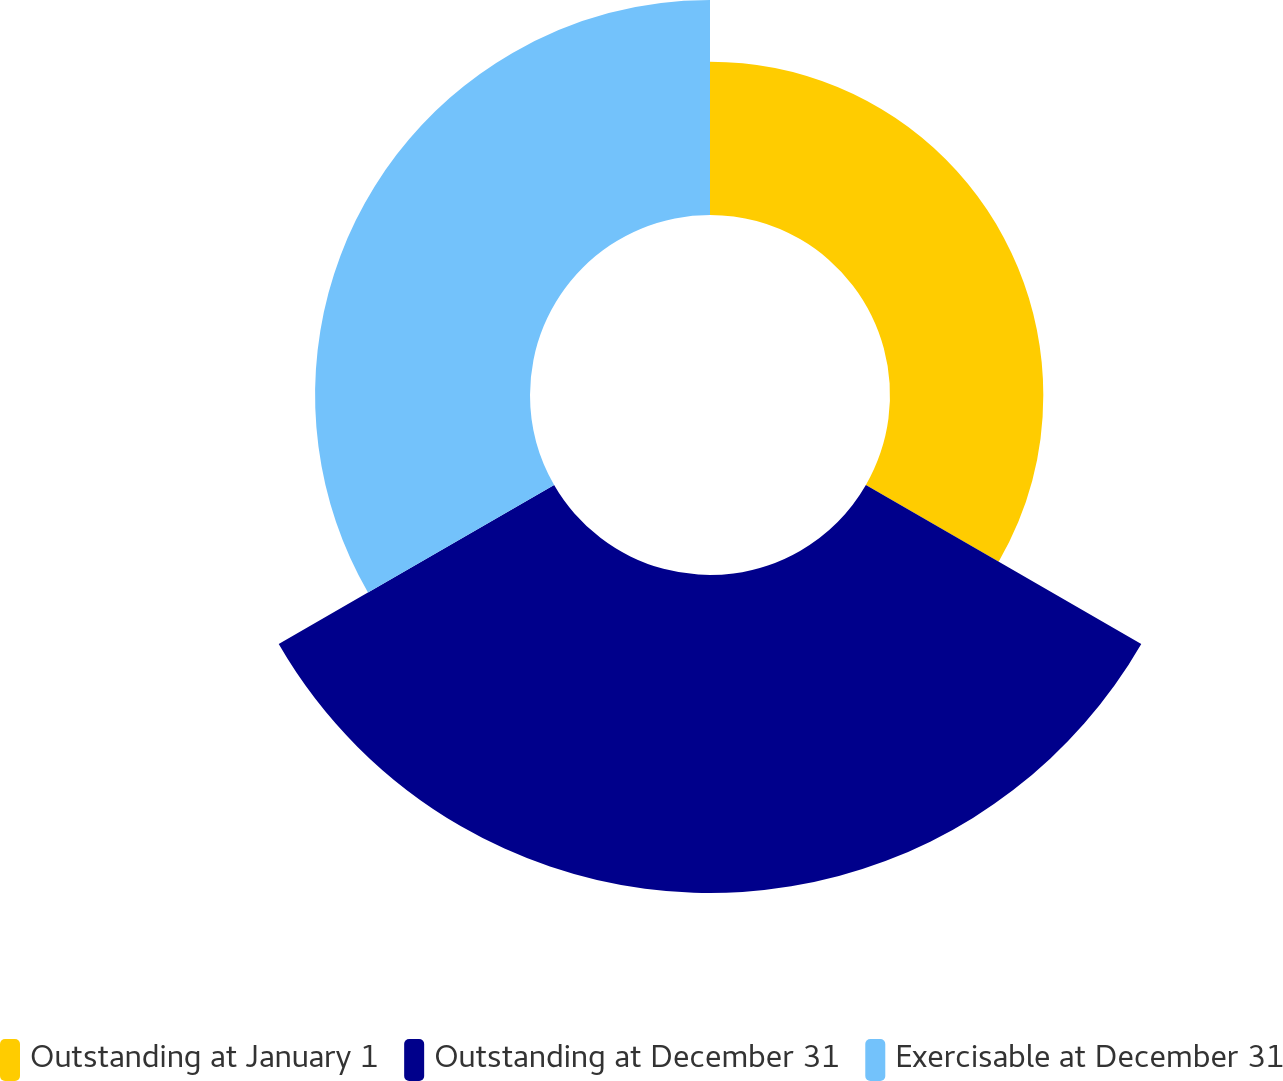Convert chart. <chart><loc_0><loc_0><loc_500><loc_500><pie_chart><fcel>Outstanding at January 1<fcel>Outstanding at December 31<fcel>Exercisable at December 31<nl><fcel>22.34%<fcel>46.34%<fcel>31.32%<nl></chart> 